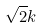Convert formula to latex. <formula><loc_0><loc_0><loc_500><loc_500>\sqrt { 2 } k</formula> 